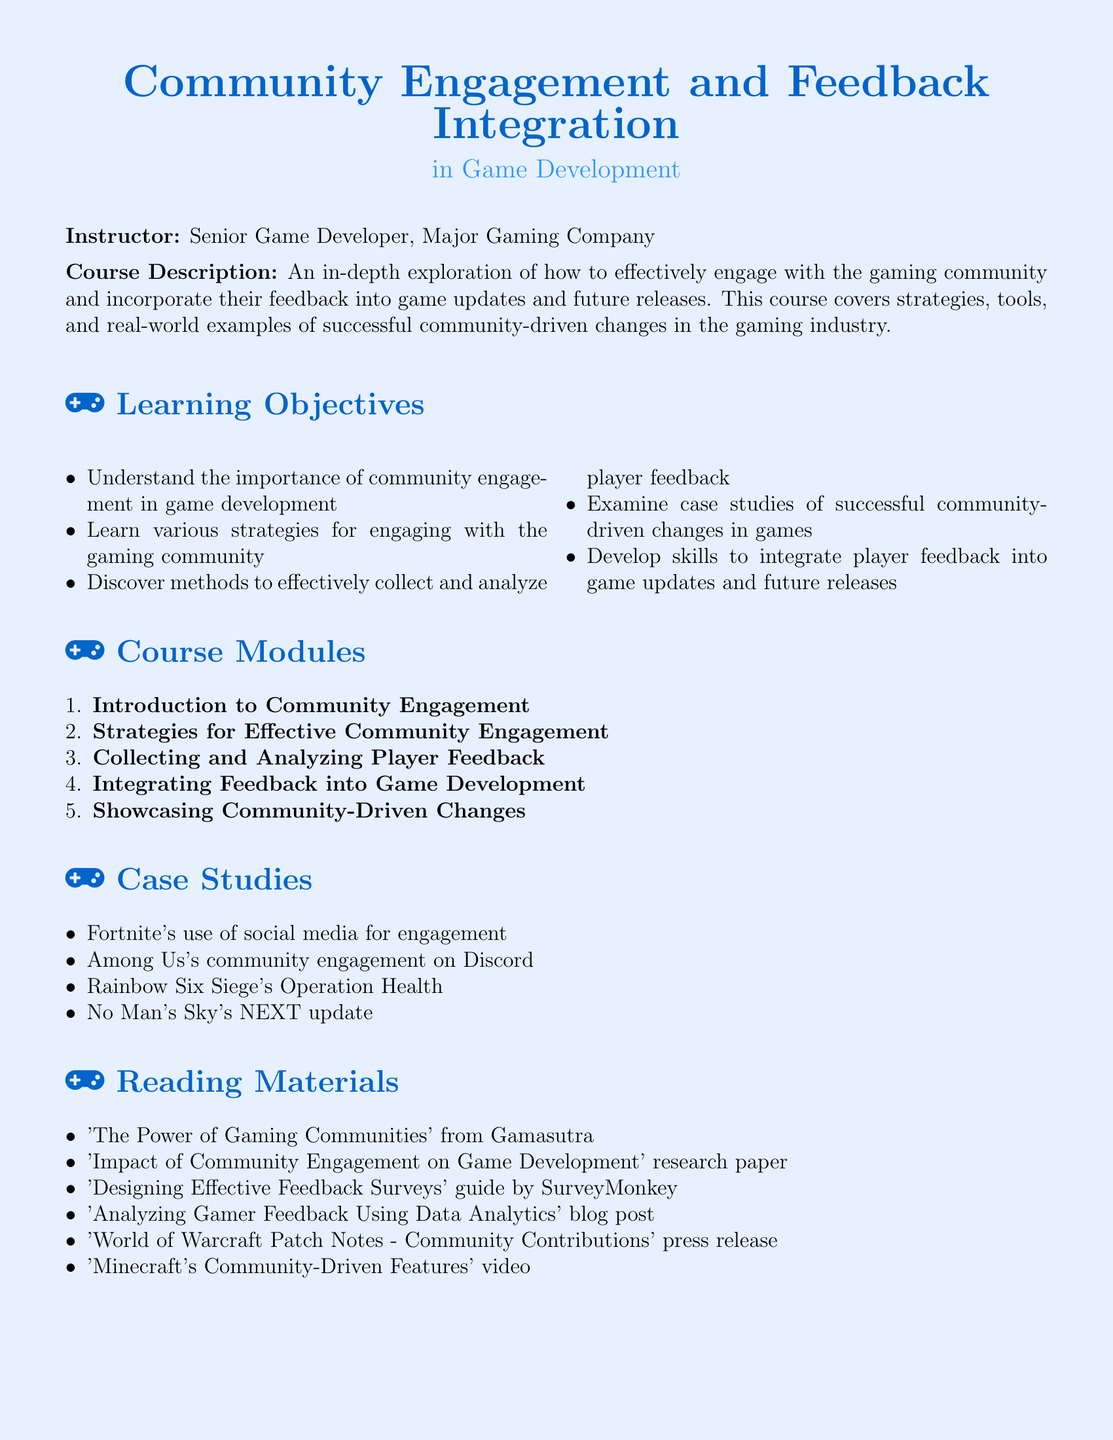What is the title of the syllabus? The title of the syllabus is explicitly stated at the beginning of the document.
Answer: Community Engagement and Feedback Integration Who is the instructor of the course? The instructor's name and title are clearly mentioned in the document.
Answer: Senior Game Developer, Major Gaming Company How many learning objectives are there? The document lists a total of five learning objectives related to community engagement strategies.
Answer: 5 What is one of the case studies mentioned? The document includes specific examples of case studies within the section on case studies.
Answer: Fortnite's use of social media for engagement Which module focuses on methods for collecting player feedback? The module names provide insight into the topics covered in the course.
Answer: Collecting and Analyzing Player Feedback What type of project is included in the assessment methods? The assessment methods outline different types of evaluations, including a practical project.
Answer: Designing a community feedback integration plan What is the color scheme used for the titles? The document specifies the colors used in the formatting, particularly for section titles.
Answer: RGB(0,100,200) and RGB(50,150,250) Where can one find a guide on designing feedback surveys? The reading materials section lists various sources relevant to community engagement.
Answer: SurveyMonkey 